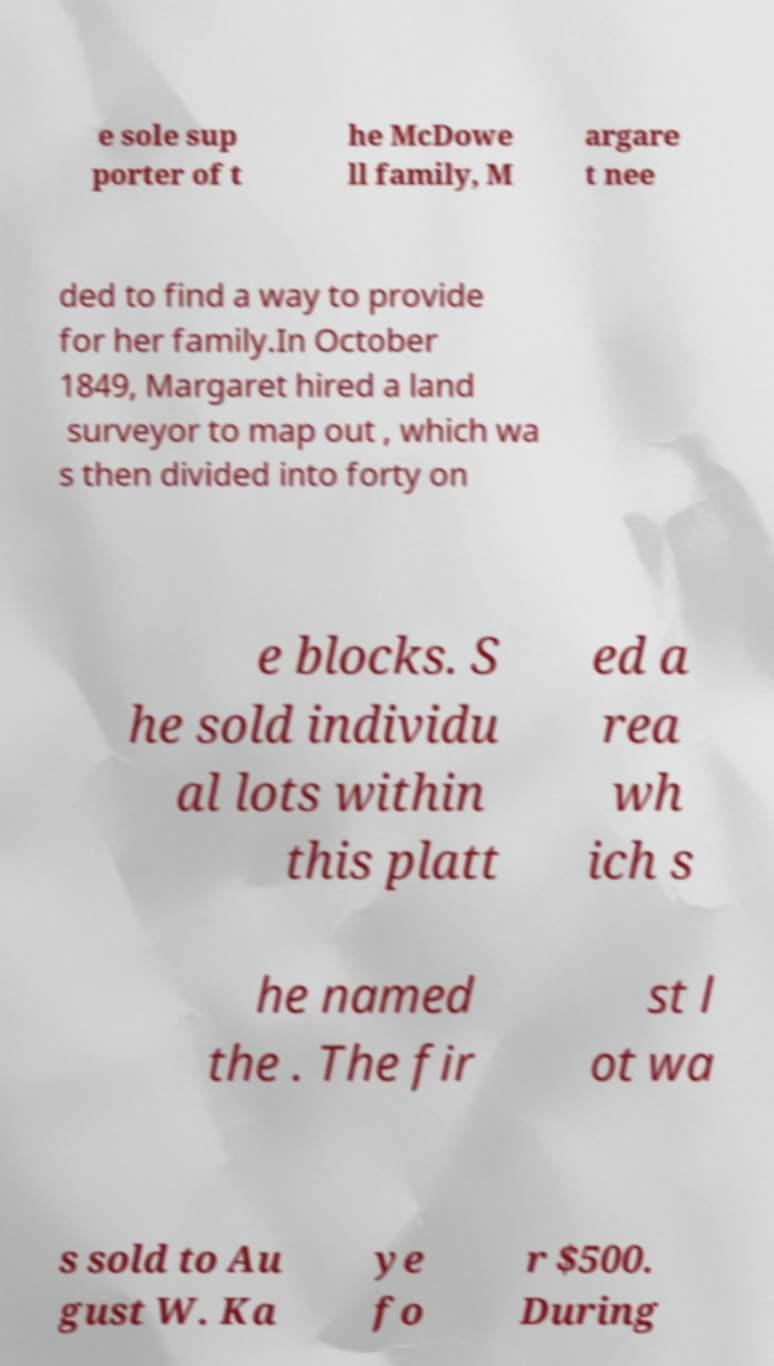Please read and relay the text visible in this image. What does it say? e sole sup porter of t he McDowe ll family, M argare t nee ded to find a way to provide for her family.In October 1849, Margaret hired a land surveyor to map out , which wa s then divided into forty on e blocks. S he sold individu al lots within this platt ed a rea wh ich s he named the . The fir st l ot wa s sold to Au gust W. Ka ye fo r $500. During 